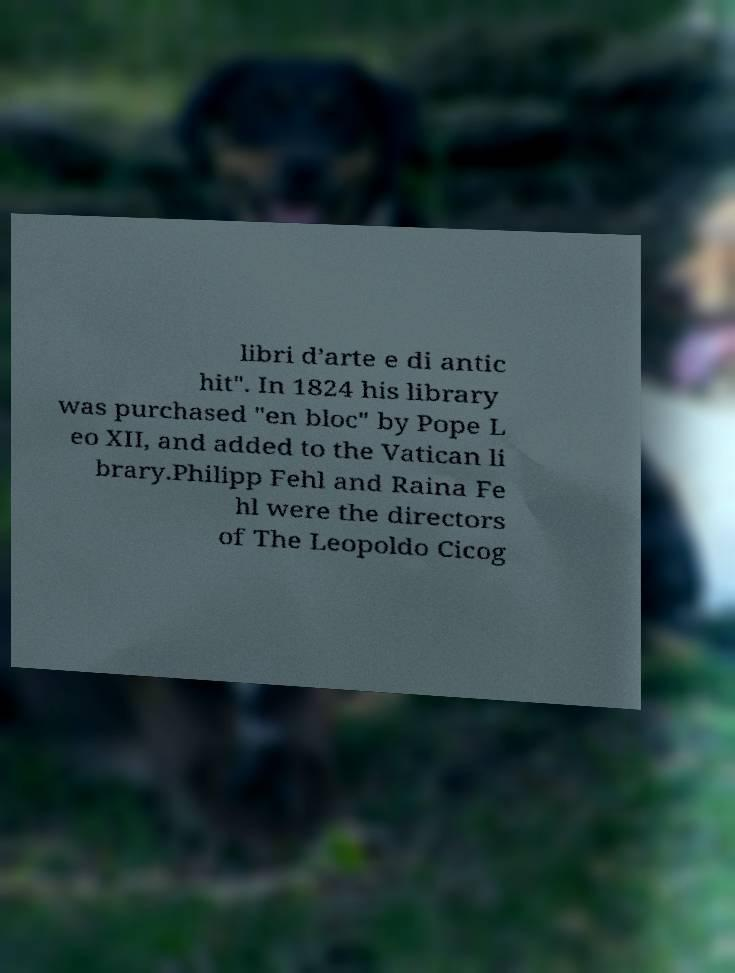What messages or text are displayed in this image? I need them in a readable, typed format. libri d’arte e di antic hit". In 1824 his library was purchased "en bloc" by Pope L eo XII, and added to the Vatican li brary.Philipp Fehl and Raina Fe hl were the directors of The Leopoldo Cicog 